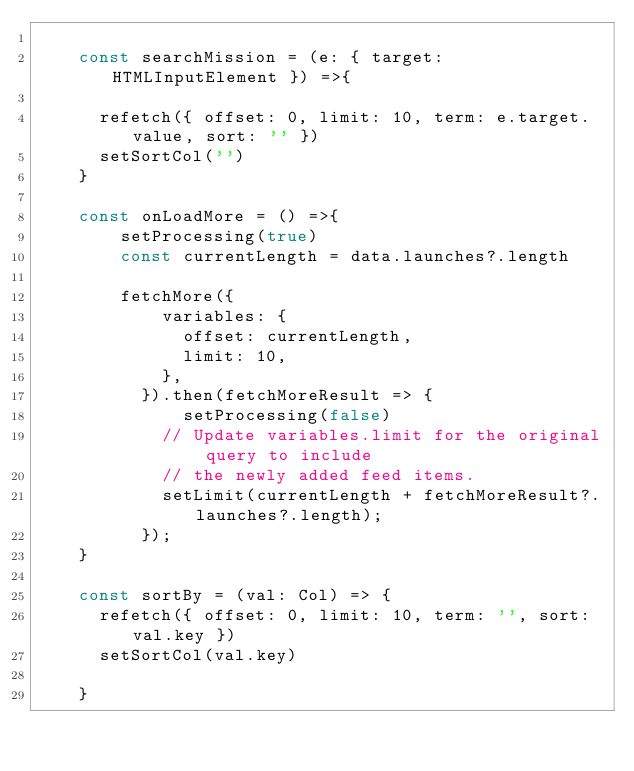Convert code to text. <code><loc_0><loc_0><loc_500><loc_500><_TypeScript_>
    const searchMission = (e: { target: HTMLInputElement }) =>{

      refetch({ offset: 0, limit: 10, term: e.target.value, sort: '' })
      setSortCol('')
    }

    const onLoadMore = () =>{
        setProcessing(true)
        const currentLength = data.launches?.length

        fetchMore({
            variables: {
              offset: currentLength,
              limit: 10,
            },
          }).then(fetchMoreResult => {
              setProcessing(false)
            // Update variables.limit for the original query to include
            // the newly added feed items.
            setLimit(currentLength + fetchMoreResult?.launches?.length);
          });
    }

    const sortBy = (val: Col) => {
      refetch({ offset: 0, limit: 10, term: '', sort: val.key })
      setSortCol(val.key)

    }
</code> 